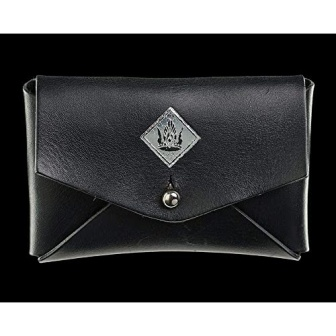Can you tell me more about the material of this wallet? The wallet appears to be made of high-quality leather, characterized by its smooth texture and uniform coloring. Leather is chosen for its durability and elegant appearance, making it a popular choice for luxury items like wallets. It's also flexible, allowing for a secure closure while still being easy to open and close. 